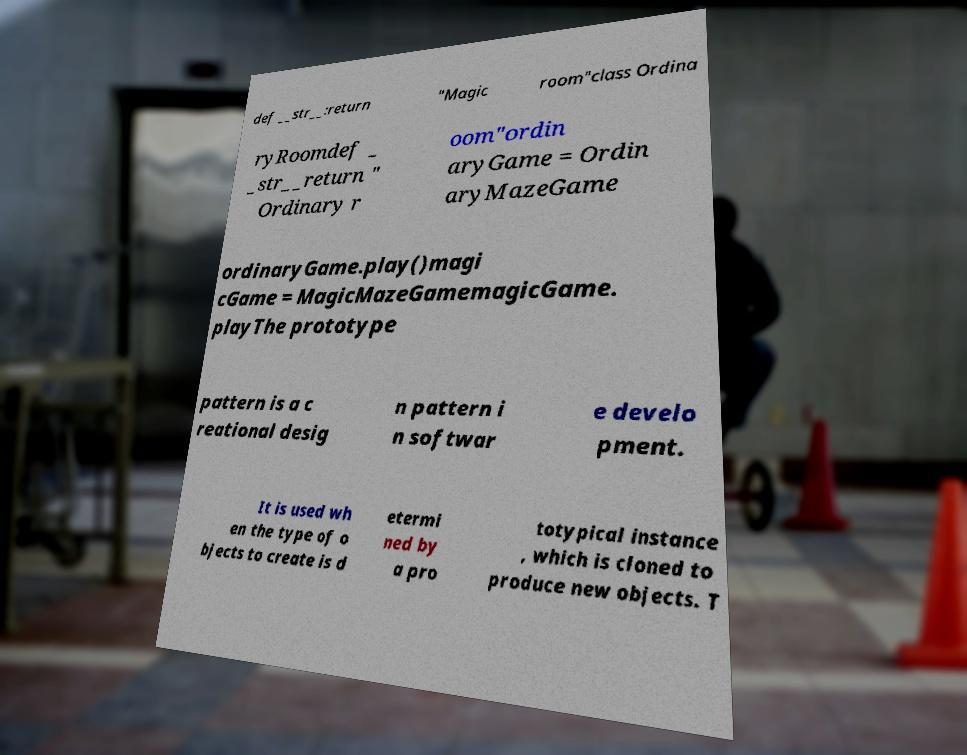There's text embedded in this image that I need extracted. Can you transcribe it verbatim? def __str__:return "Magic room"class Ordina ryRoomdef _ _str__return " Ordinary r oom"ordin aryGame = Ordin aryMazeGame ordinaryGame.play()magi cGame = MagicMazeGamemagicGame. playThe prototype pattern is a c reational desig n pattern i n softwar e develo pment. It is used wh en the type of o bjects to create is d etermi ned by a pro totypical instance , which is cloned to produce new objects. T 